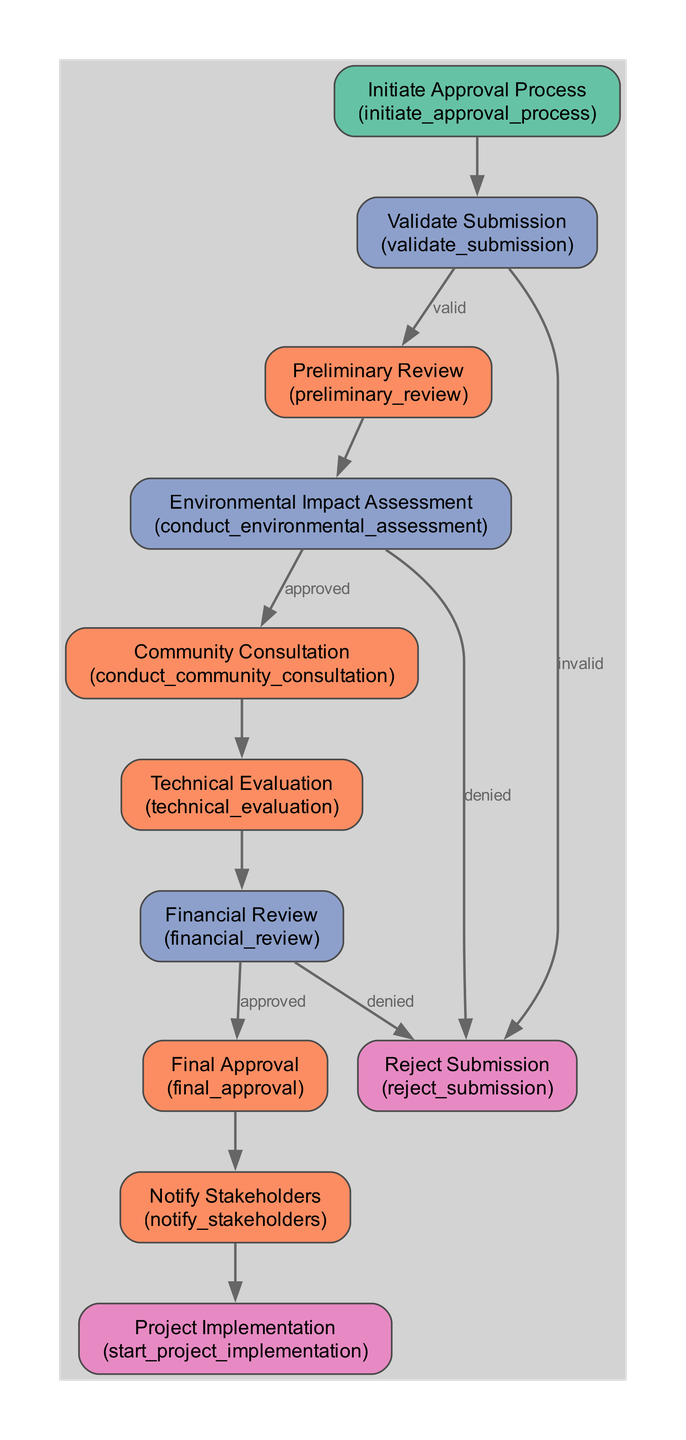What is the first step in the Civic Infrastructure Project Approval Workflow? The diagram shows the first step is "Initiate Approval Process." This indicates it's where the workflow begins with a project approval request submission.
Answer: Initiate Approval Process How many nodes are there in the workflow? By examining the flowchart, I count a total of 10 nodes representing various steps and decisions in the approval process.
Answer: 10 What condition leads to "Reject Submission" from "Validate Submission"? The diagram indicates that if the submission is "invalid," it leads directly to "Reject Submission," highlighting the path taken when documents are lacking.
Answer: invalid What is the next step after "Community Consultation"? According to the diagram, after completing "Community Consultation," the next step is "Technical Evaluation," indicating a progression in the workflow.
Answer: Technical Evaluation Which department conducts the "Preliminary Review"? The diagram indicates that the "Preliminary Review" is performed by the Municipal Planning Department, clearly stating the responsible body for this initial assessment.
Answer: Municipal Planning Department What happens if the "Financial Review" is denied? The workflow specifies that if the "Financial Review" is denied, it leads to "Reject Submission," emphasizing the consequences of financial assessment failures.
Answer: Reject Submission What is the final action taken after "Final Approval"? The final action described in the diagram is "Notify Stakeholders," which communicates the approval decision to relevant parties involved in the project.
Answer: Notify Stakeholders Which step involves evaluating potential environmental effects? The diagram shows that the step "Environmental Impact Assessment" is dedicated to evaluating the project's potential environmental impacts, underlining its importance in the workflow.
Answer: Environmental Impact Assessment What is required before moving to "Technical Evaluation"? The diagram indicates that completing "Community Consultation" is required before proceeding to "Technical Evaluation," demonstrating the sequential nature of the assessment process.
Answer: Community Consultation 